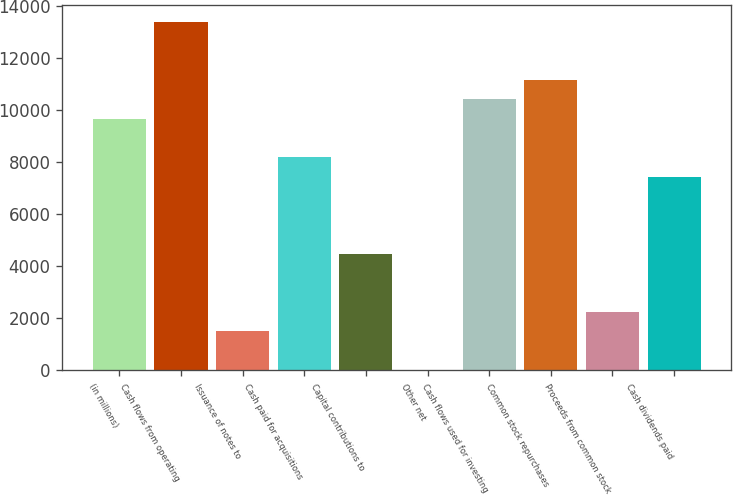<chart> <loc_0><loc_0><loc_500><loc_500><bar_chart><fcel>(in millions)<fcel>Cash flows from operating<fcel>Issuance of notes to<fcel>Cash paid for acquisitions<fcel>Capital contributions to<fcel>Other net<fcel>Cash flows used for investing<fcel>Common stock repurchases<fcel>Proceeds from common stock<fcel>Cash dividends paid<nl><fcel>9675.8<fcel>13393.8<fcel>1496.2<fcel>8188.6<fcel>4470.6<fcel>9<fcel>10419.4<fcel>11163<fcel>2239.8<fcel>7445<nl></chart> 